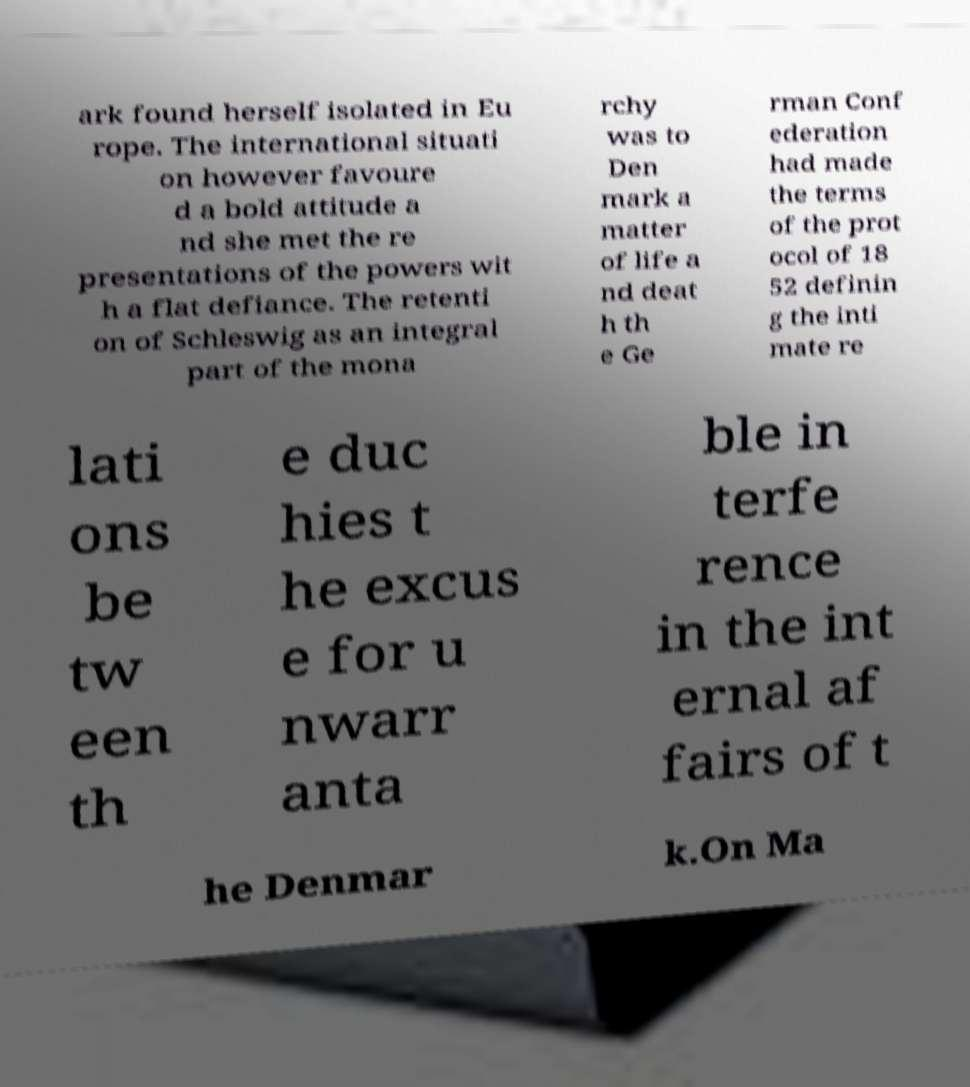Can you accurately transcribe the text from the provided image for me? ark found herself isolated in Eu rope. The international situati on however favoure d a bold attitude a nd she met the re presentations of the powers wit h a flat defiance. The retenti on of Schleswig as an integral part of the mona rchy was to Den mark a matter of life a nd deat h th e Ge rman Conf ederation had made the terms of the prot ocol of 18 52 definin g the inti mate re lati ons be tw een th e duc hies t he excus e for u nwarr anta ble in terfe rence in the int ernal af fairs of t he Denmar k.On Ma 